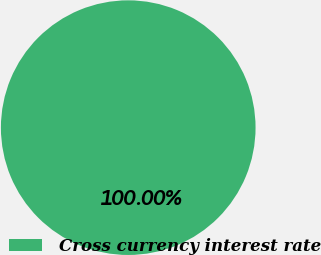Convert chart. <chart><loc_0><loc_0><loc_500><loc_500><pie_chart><fcel>Cross currency interest rate<nl><fcel>100.0%<nl></chart> 